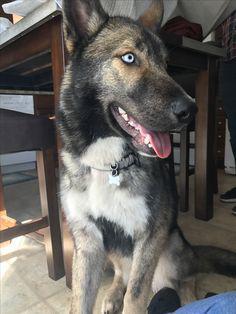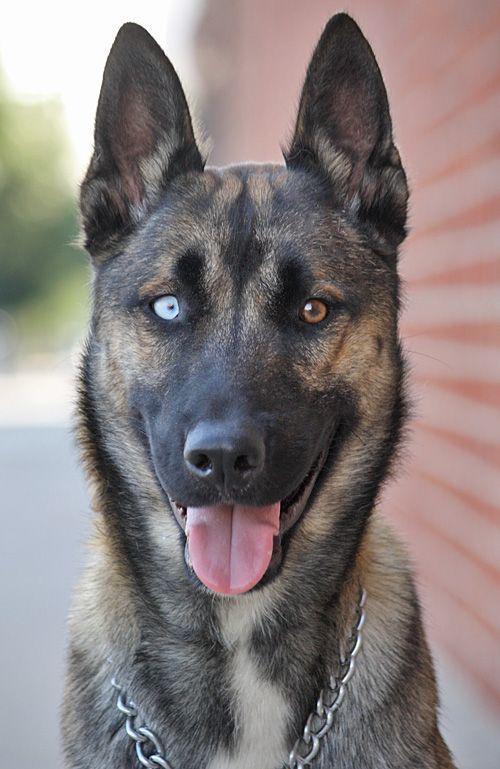The first image is the image on the left, the second image is the image on the right. Considering the images on both sides, is "There are at least two dogs in the left image." valid? Answer yes or no. No. The first image is the image on the left, the second image is the image on the right. Analyze the images presented: Is the assertion "There are two dogs together outside in the image on the left." valid? Answer yes or no. No. 